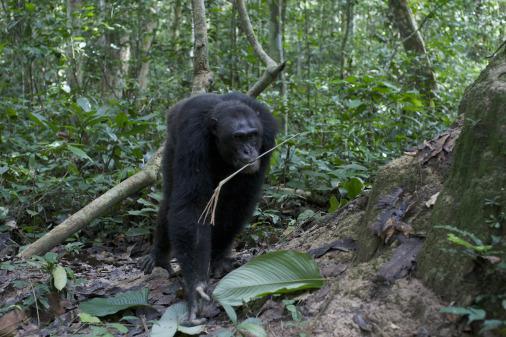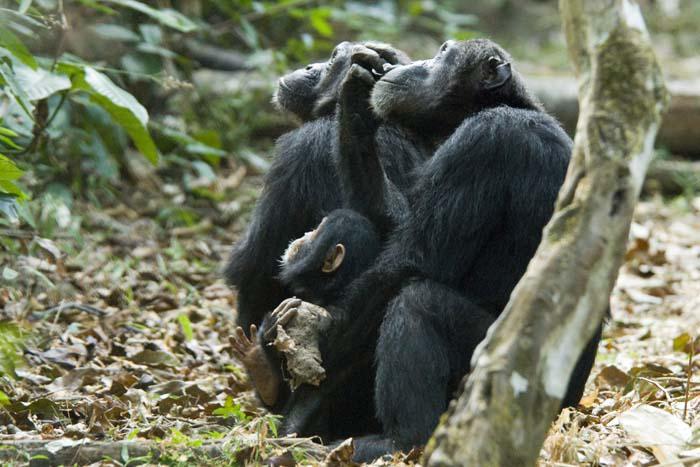The first image is the image on the left, the second image is the image on the right. Assess this claim about the two images: "There are more animals in the image on the left.". Correct or not? Answer yes or no. No. The first image is the image on the left, the second image is the image on the right. Given the left and right images, does the statement "One image shows a close-mouthed chimp holding a stick and poking it down at something." hold true? Answer yes or no. No. 